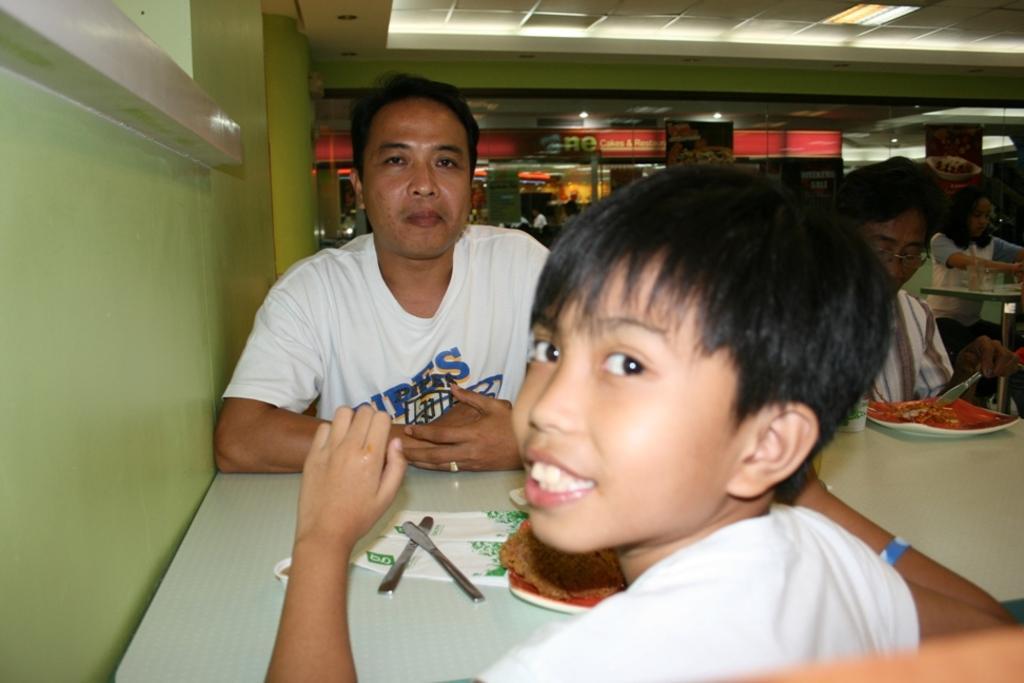Describe this image in one or two sentences. In this picture we can observe a man and a boy sitting in front of each other in the chairs. We can observe a table on which there are knives, tissues and some food are placed. In the background there are some people sitting in the chair. We can observe white color light in the ceiling. On the left there is a green color wall. 